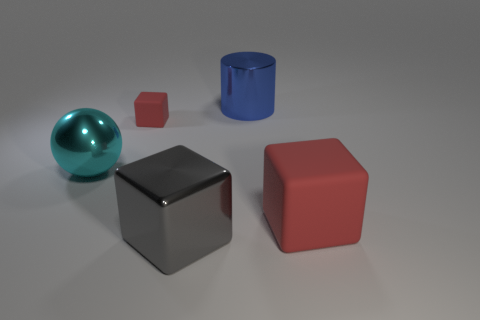Add 5 large red things. How many objects exist? 10 Subtract all cylinders. How many objects are left? 4 Add 5 large cyan spheres. How many large cyan spheres are left? 6 Add 1 small cyan rubber objects. How many small cyan rubber objects exist? 1 Subtract 0 brown cylinders. How many objects are left? 5 Subtract all rubber blocks. Subtract all big cyan spheres. How many objects are left? 2 